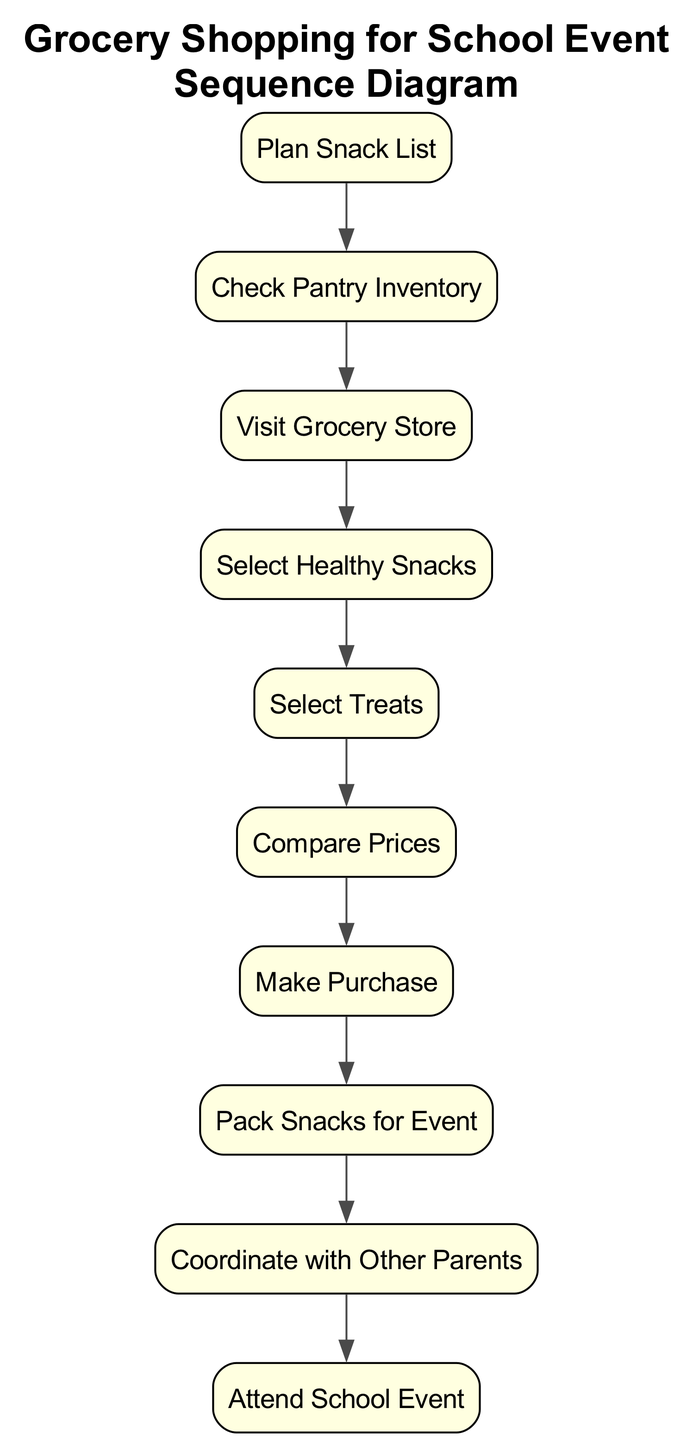What is the first action in the sequence? The first action in the sequence is "Plan Snack List." It is the initial step that starts the grocery shopping process for snacks and sweets intended for the school event.
Answer: Plan Snack List How many actions are in the diagram? By counting the listed actions, there are a total of 10 actions depicted in the sequence diagram, each representing a step in the grocery shopping process.
Answer: 10 What is the last action in the sequence? The last action in the sequence is "Attend School Event." This represents the final step after all preparations and purchases have been completed.
Answer: Attend School Event Which action occurs after "Select Healthy Snacks"? The action that occurs after "Select Healthy Snacks" is "Select Treats." This indicates the flow of decisions regarding snack choices, moving from healthy options to sweeter treats.
Answer: Select Treats What is the relationship between "Coordinate with Other Parents" and "Pack Snacks for Event"? The relationship indicates that "Coordinate with Other Parents" occurs prior to "Pack Snacks for Event." This step ensures that there is a balanced selection of snacks before final packing.
Answer: Prior How many snack selection actions are in the sequence? There are two snack selection actions: "Select Healthy Snacks" and "Select Treats." Both represent decision-making phases during the shopping process.
Answer: 2 What action follows "Make Purchase"? The action that follows "Make Purchase" is "Pack Snacks for Event." After purchasing the snacks, the next step is to prepare them for the event, showing a direct sequential flow.
Answer: Pack Snacks for Event Is "Compare Prices" before or after "Make Purchase"? "Compare Prices" is before "Make Purchase." This indicates that price evaluation is a step required prior to completing any purchases to ensure cost-effectiveness.
Answer: Before What action is directly connected to "Attend School Event"? The action directly connected to "Attend School Event" is "Pack Snacks for Event." This reflects the packing preparation that leads up to the event itself.
Answer: Pack Snacks for Event 